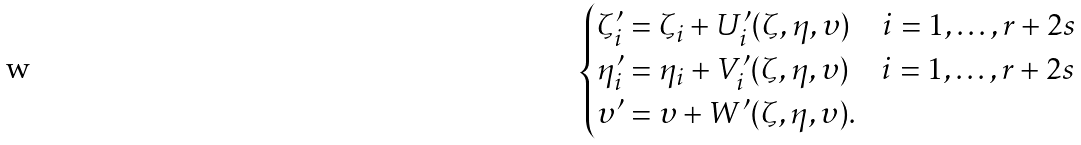<formula> <loc_0><loc_0><loc_500><loc_500>\begin{cases} \zeta ^ { \prime } _ { i } = \zeta _ { i } + U ^ { \prime } _ { i } ( \zeta , \eta , \upsilon ) \quad i = 1 , \dots , r + 2 s \\ \eta ^ { \prime } _ { i } = \eta _ { i } + V ^ { \prime } _ { i } ( \zeta , \eta , \upsilon ) \quad i = 1 , \dots , r + 2 s \\ \upsilon ^ { \prime } = \upsilon + W ^ { \prime } ( \zeta , \eta , \upsilon ) . \end{cases}</formula> 